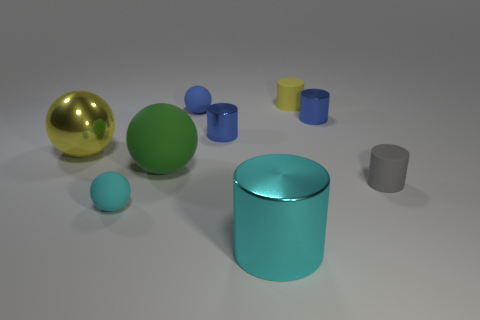Subtract 2 cylinders. How many cylinders are left? 3 Subtract all gray matte cylinders. How many cylinders are left? 4 Subtract all cyan cylinders. How many cylinders are left? 4 Subtract all brown cylinders. Subtract all cyan balls. How many cylinders are left? 5 Subtract all cylinders. How many objects are left? 4 Add 4 small cyan matte balls. How many small cyan matte balls exist? 5 Subtract 1 green spheres. How many objects are left? 8 Subtract all small blue shiny objects. Subtract all yellow metal objects. How many objects are left? 6 Add 3 small blue cylinders. How many small blue cylinders are left? 5 